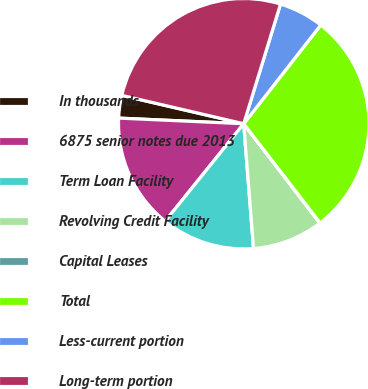Convert chart to OTSL. <chart><loc_0><loc_0><loc_500><loc_500><pie_chart><fcel>In thousands<fcel>6875 senior notes due 2013<fcel>Term Loan Facility<fcel>Revolving Credit Facility<fcel>Capital Leases<fcel>Total<fcel>Less-current portion<fcel>Long-term portion<nl><fcel>2.92%<fcel>14.92%<fcel>12.04%<fcel>9.16%<fcel>0.04%<fcel>29.0%<fcel>5.8%<fcel>26.11%<nl></chart> 